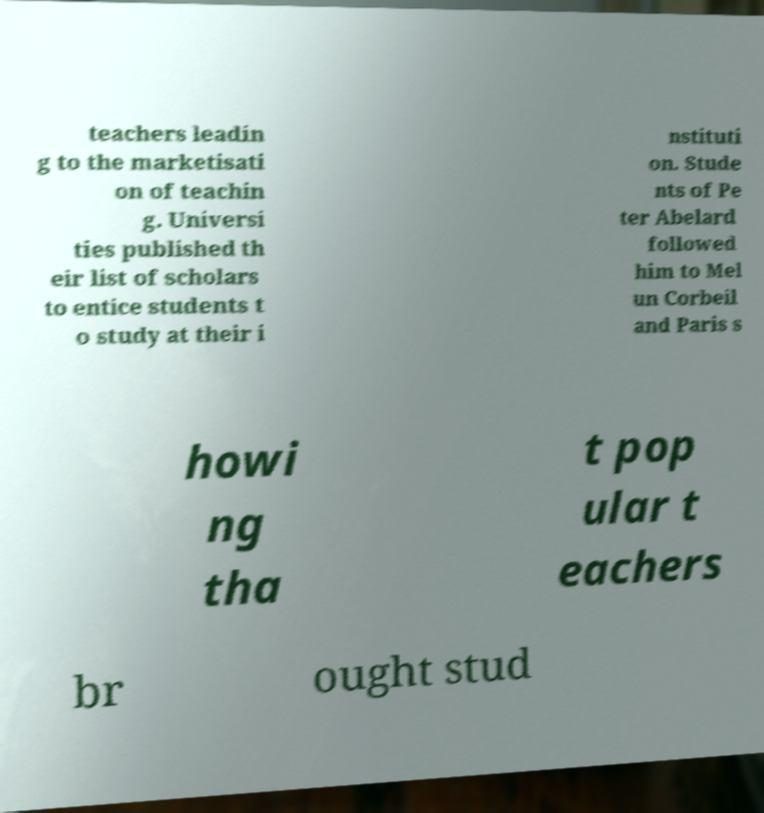I need the written content from this picture converted into text. Can you do that? teachers leadin g to the marketisati on of teachin g. Universi ties published th eir list of scholars to entice students t o study at their i nstituti on. Stude nts of Pe ter Abelard followed him to Mel un Corbeil and Paris s howi ng tha t pop ular t eachers br ought stud 